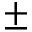Convert formula to latex. <formula><loc_0><loc_0><loc_500><loc_500>\pm</formula> 